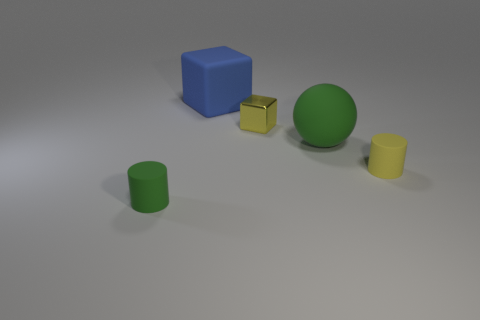Add 5 green rubber things. How many objects exist? 10 Subtract all cubes. How many objects are left? 3 Subtract all yellow cylinders. How many cylinders are left? 1 Subtract all gray cylinders. Subtract all brown balls. How many cylinders are left? 2 Subtract all cyan spheres. How many purple cylinders are left? 0 Add 3 tiny shiny cubes. How many tiny shiny cubes are left? 4 Add 5 big metallic objects. How many big metallic objects exist? 5 Subtract 0 purple cylinders. How many objects are left? 5 Subtract all yellow metal cylinders. Subtract all large objects. How many objects are left? 3 